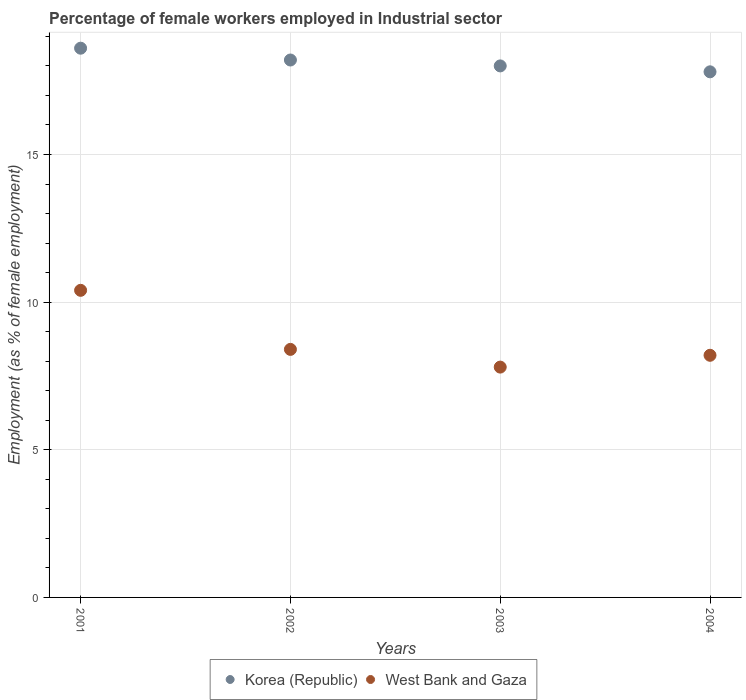Is the number of dotlines equal to the number of legend labels?
Provide a short and direct response. Yes. What is the percentage of females employed in Industrial sector in West Bank and Gaza in 2002?
Provide a succinct answer. 8.4. Across all years, what is the maximum percentage of females employed in Industrial sector in Korea (Republic)?
Give a very brief answer. 18.6. Across all years, what is the minimum percentage of females employed in Industrial sector in West Bank and Gaza?
Ensure brevity in your answer.  7.8. In which year was the percentage of females employed in Industrial sector in Korea (Republic) maximum?
Your answer should be very brief. 2001. In which year was the percentage of females employed in Industrial sector in Korea (Republic) minimum?
Offer a terse response. 2004. What is the total percentage of females employed in Industrial sector in West Bank and Gaza in the graph?
Your answer should be very brief. 34.8. What is the difference between the percentage of females employed in Industrial sector in Korea (Republic) in 2001 and that in 2004?
Give a very brief answer. 0.8. What is the difference between the percentage of females employed in Industrial sector in Korea (Republic) in 2002 and the percentage of females employed in Industrial sector in West Bank and Gaza in 2003?
Keep it short and to the point. 10.4. What is the average percentage of females employed in Industrial sector in Korea (Republic) per year?
Give a very brief answer. 18.15. In the year 2001, what is the difference between the percentage of females employed in Industrial sector in Korea (Republic) and percentage of females employed in Industrial sector in West Bank and Gaza?
Provide a succinct answer. 8.2. In how many years, is the percentage of females employed in Industrial sector in West Bank and Gaza greater than 1 %?
Provide a succinct answer. 4. What is the ratio of the percentage of females employed in Industrial sector in West Bank and Gaza in 2002 to that in 2003?
Your answer should be very brief. 1.08. Is the percentage of females employed in Industrial sector in West Bank and Gaza in 2002 less than that in 2004?
Provide a succinct answer. No. Is the difference between the percentage of females employed in Industrial sector in Korea (Republic) in 2001 and 2002 greater than the difference between the percentage of females employed in Industrial sector in West Bank and Gaza in 2001 and 2002?
Your answer should be very brief. No. What is the difference between the highest and the second highest percentage of females employed in Industrial sector in Korea (Republic)?
Offer a very short reply. 0.4. What is the difference between the highest and the lowest percentage of females employed in Industrial sector in Korea (Republic)?
Make the answer very short. 0.8. In how many years, is the percentage of females employed in Industrial sector in Korea (Republic) greater than the average percentage of females employed in Industrial sector in Korea (Republic) taken over all years?
Provide a succinct answer. 2. Is the sum of the percentage of females employed in Industrial sector in West Bank and Gaza in 2002 and 2004 greater than the maximum percentage of females employed in Industrial sector in Korea (Republic) across all years?
Offer a very short reply. No. Does the percentage of females employed in Industrial sector in West Bank and Gaza monotonically increase over the years?
Give a very brief answer. No. Is the percentage of females employed in Industrial sector in Korea (Republic) strictly greater than the percentage of females employed in Industrial sector in West Bank and Gaza over the years?
Your answer should be compact. Yes. How many dotlines are there?
Your answer should be very brief. 2. Does the graph contain any zero values?
Ensure brevity in your answer.  No. How are the legend labels stacked?
Keep it short and to the point. Horizontal. What is the title of the graph?
Give a very brief answer. Percentage of female workers employed in Industrial sector. Does "New Zealand" appear as one of the legend labels in the graph?
Make the answer very short. No. What is the label or title of the Y-axis?
Your answer should be very brief. Employment (as % of female employment). What is the Employment (as % of female employment) in Korea (Republic) in 2001?
Give a very brief answer. 18.6. What is the Employment (as % of female employment) of West Bank and Gaza in 2001?
Provide a short and direct response. 10.4. What is the Employment (as % of female employment) in Korea (Republic) in 2002?
Your response must be concise. 18.2. What is the Employment (as % of female employment) in West Bank and Gaza in 2002?
Ensure brevity in your answer.  8.4. What is the Employment (as % of female employment) in Korea (Republic) in 2003?
Your answer should be compact. 18. What is the Employment (as % of female employment) of West Bank and Gaza in 2003?
Your answer should be very brief. 7.8. What is the Employment (as % of female employment) in Korea (Republic) in 2004?
Your answer should be very brief. 17.8. What is the Employment (as % of female employment) in West Bank and Gaza in 2004?
Provide a succinct answer. 8.2. Across all years, what is the maximum Employment (as % of female employment) in Korea (Republic)?
Make the answer very short. 18.6. Across all years, what is the maximum Employment (as % of female employment) of West Bank and Gaza?
Give a very brief answer. 10.4. Across all years, what is the minimum Employment (as % of female employment) in Korea (Republic)?
Your answer should be compact. 17.8. Across all years, what is the minimum Employment (as % of female employment) of West Bank and Gaza?
Offer a terse response. 7.8. What is the total Employment (as % of female employment) of Korea (Republic) in the graph?
Make the answer very short. 72.6. What is the total Employment (as % of female employment) of West Bank and Gaza in the graph?
Keep it short and to the point. 34.8. What is the difference between the Employment (as % of female employment) in Korea (Republic) in 2001 and that in 2002?
Your answer should be very brief. 0.4. What is the difference between the Employment (as % of female employment) in West Bank and Gaza in 2001 and that in 2002?
Your answer should be very brief. 2. What is the difference between the Employment (as % of female employment) in Korea (Republic) in 2003 and that in 2004?
Your answer should be compact. 0.2. What is the difference between the Employment (as % of female employment) of West Bank and Gaza in 2003 and that in 2004?
Provide a succinct answer. -0.4. What is the difference between the Employment (as % of female employment) of Korea (Republic) in 2001 and the Employment (as % of female employment) of West Bank and Gaza in 2004?
Offer a very short reply. 10.4. What is the difference between the Employment (as % of female employment) in Korea (Republic) in 2002 and the Employment (as % of female employment) in West Bank and Gaza in 2004?
Give a very brief answer. 10. What is the difference between the Employment (as % of female employment) in Korea (Republic) in 2003 and the Employment (as % of female employment) in West Bank and Gaza in 2004?
Provide a short and direct response. 9.8. What is the average Employment (as % of female employment) in Korea (Republic) per year?
Your response must be concise. 18.15. In the year 2001, what is the difference between the Employment (as % of female employment) in Korea (Republic) and Employment (as % of female employment) in West Bank and Gaza?
Your answer should be compact. 8.2. In the year 2002, what is the difference between the Employment (as % of female employment) in Korea (Republic) and Employment (as % of female employment) in West Bank and Gaza?
Offer a terse response. 9.8. In the year 2003, what is the difference between the Employment (as % of female employment) of Korea (Republic) and Employment (as % of female employment) of West Bank and Gaza?
Provide a succinct answer. 10.2. In the year 2004, what is the difference between the Employment (as % of female employment) in Korea (Republic) and Employment (as % of female employment) in West Bank and Gaza?
Your answer should be very brief. 9.6. What is the ratio of the Employment (as % of female employment) in West Bank and Gaza in 2001 to that in 2002?
Offer a terse response. 1.24. What is the ratio of the Employment (as % of female employment) of Korea (Republic) in 2001 to that in 2003?
Make the answer very short. 1.03. What is the ratio of the Employment (as % of female employment) of Korea (Republic) in 2001 to that in 2004?
Provide a short and direct response. 1.04. What is the ratio of the Employment (as % of female employment) in West Bank and Gaza in 2001 to that in 2004?
Ensure brevity in your answer.  1.27. What is the ratio of the Employment (as % of female employment) in Korea (Republic) in 2002 to that in 2003?
Provide a short and direct response. 1.01. What is the ratio of the Employment (as % of female employment) in West Bank and Gaza in 2002 to that in 2003?
Make the answer very short. 1.08. What is the ratio of the Employment (as % of female employment) in Korea (Republic) in 2002 to that in 2004?
Provide a succinct answer. 1.02. What is the ratio of the Employment (as % of female employment) of West Bank and Gaza in 2002 to that in 2004?
Offer a terse response. 1.02. What is the ratio of the Employment (as % of female employment) of Korea (Republic) in 2003 to that in 2004?
Your answer should be very brief. 1.01. What is the ratio of the Employment (as % of female employment) of West Bank and Gaza in 2003 to that in 2004?
Provide a short and direct response. 0.95. What is the difference between the highest and the lowest Employment (as % of female employment) of Korea (Republic)?
Keep it short and to the point. 0.8. What is the difference between the highest and the lowest Employment (as % of female employment) of West Bank and Gaza?
Ensure brevity in your answer.  2.6. 